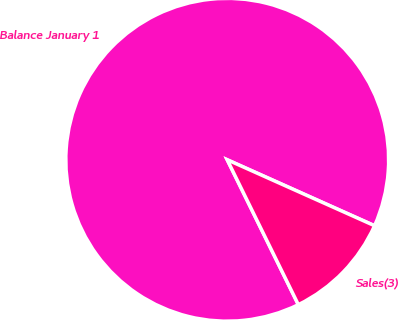<chart> <loc_0><loc_0><loc_500><loc_500><pie_chart><fcel>Balance January 1<fcel>Sales(3)<nl><fcel>88.96%<fcel>11.04%<nl></chart> 